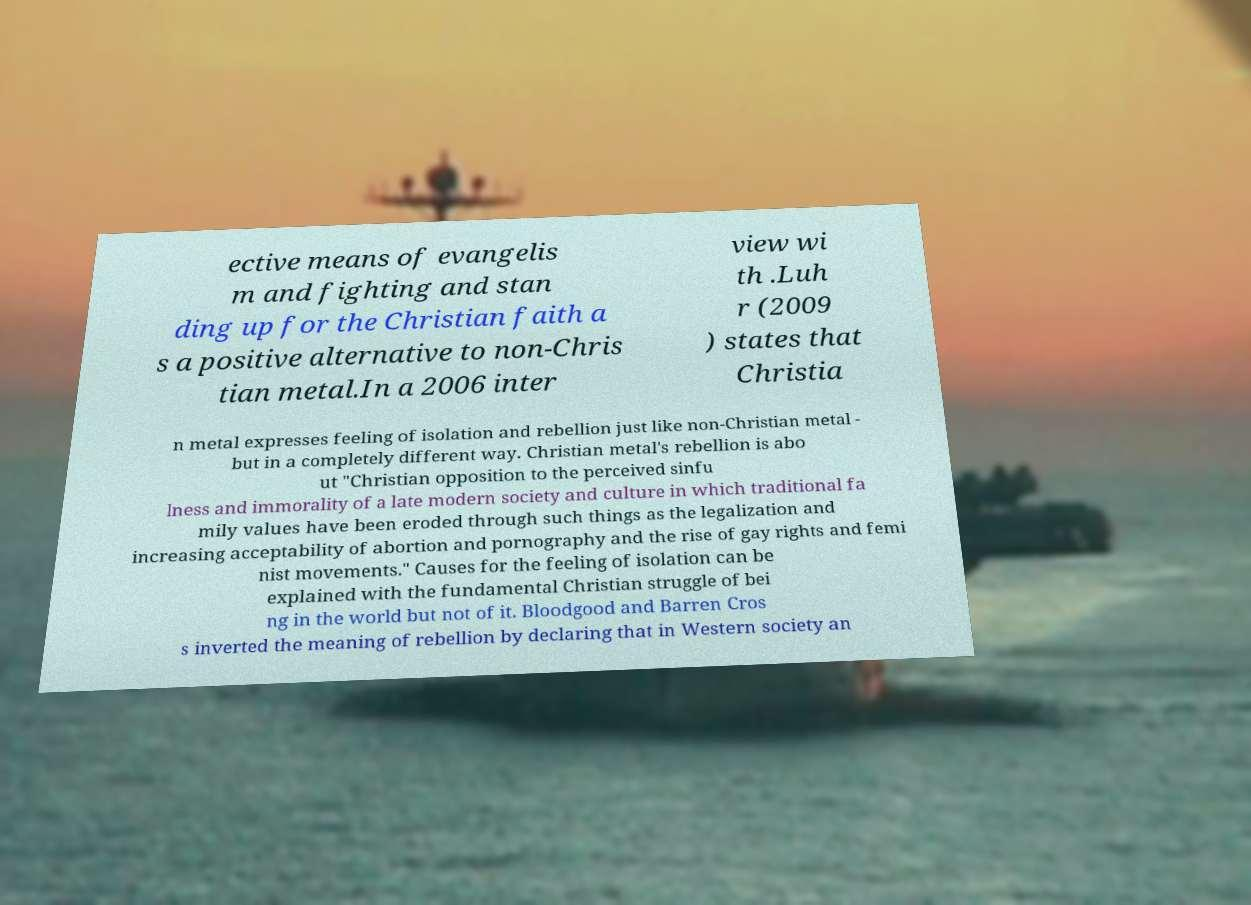For documentation purposes, I need the text within this image transcribed. Could you provide that? ective means of evangelis m and fighting and stan ding up for the Christian faith a s a positive alternative to non-Chris tian metal.In a 2006 inter view wi th .Luh r (2009 ) states that Christia n metal expresses feeling of isolation and rebellion just like non-Christian metal - but in a completely different way. Christian metal's rebellion is abo ut "Christian opposition to the perceived sinfu lness and immorality of a late modern society and culture in which traditional fa mily values have been eroded through such things as the legalization and increasing acceptability of abortion and pornography and the rise of gay rights and femi nist movements." Causes for the feeling of isolation can be explained with the fundamental Christian struggle of bei ng in the world but not of it. Bloodgood and Barren Cros s inverted the meaning of rebellion by declaring that in Western society an 